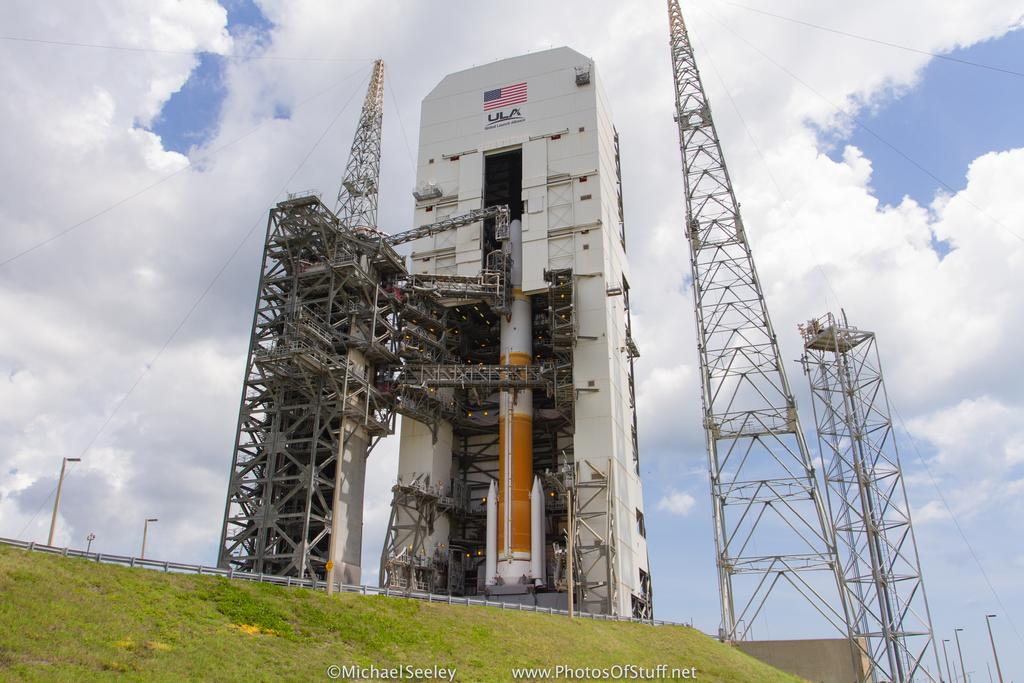<image>
Create a compact narrative representing the image presented. A rocket platform with an American flag says ULA underneath it. 